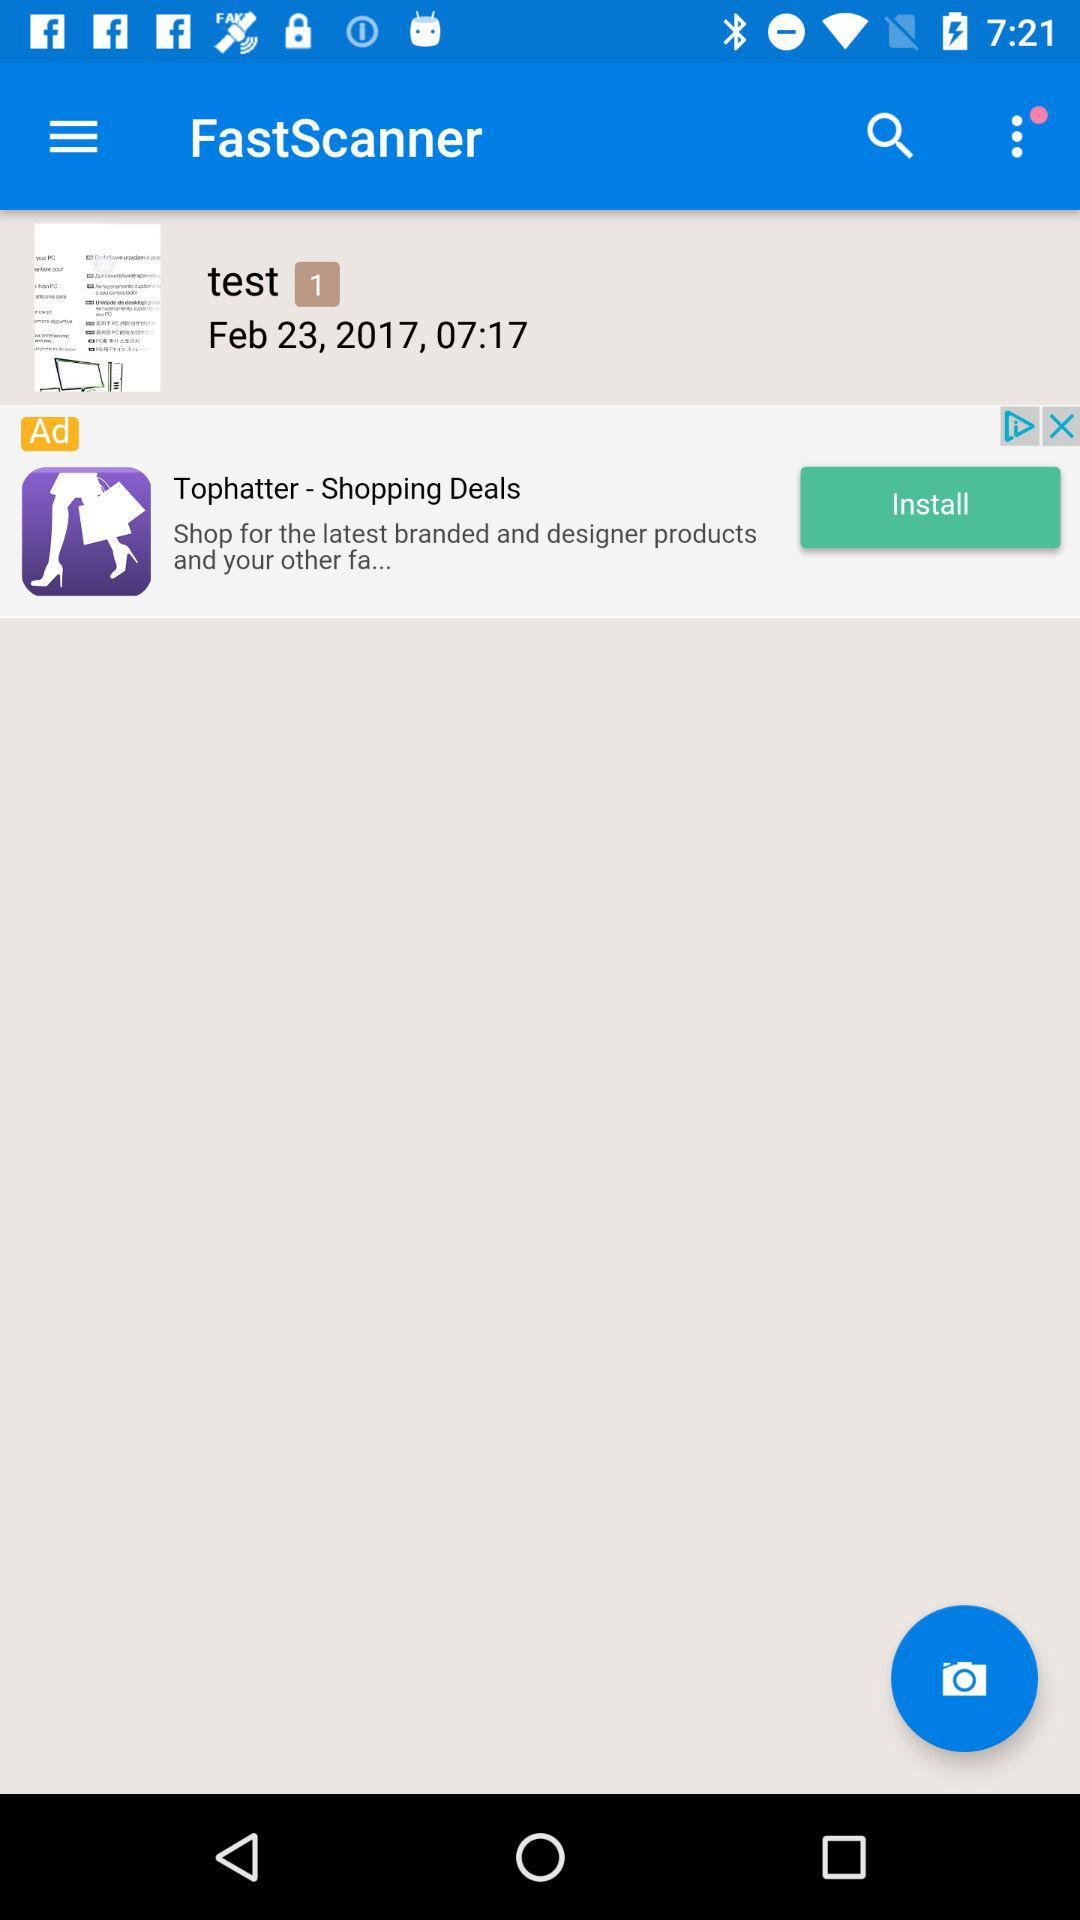What is the date the test image was saved? The date is February 23, 2017. 